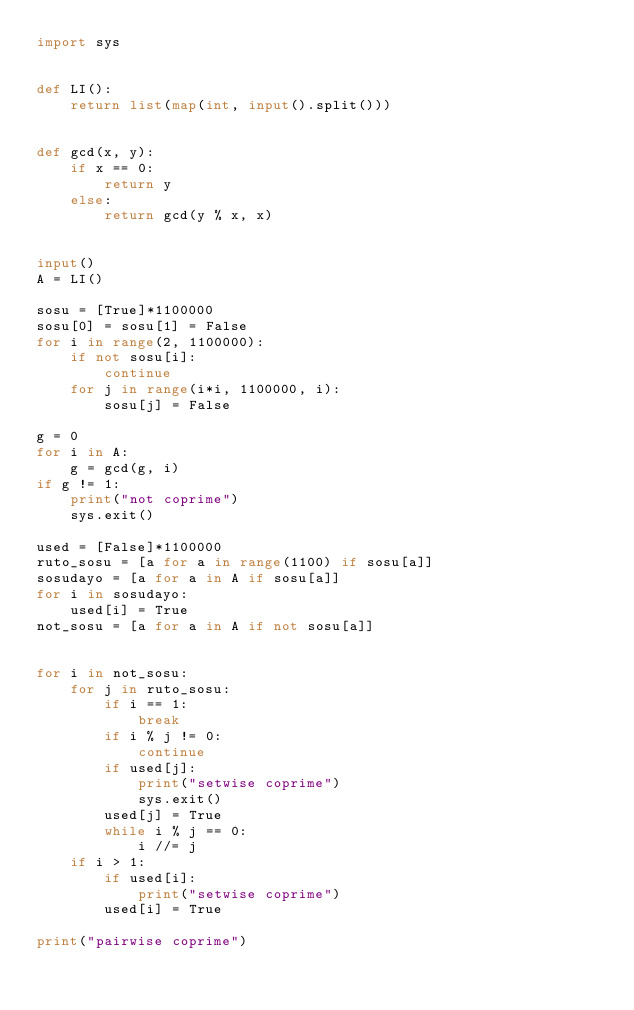Convert code to text. <code><loc_0><loc_0><loc_500><loc_500><_Python_>import sys


def LI():
    return list(map(int, input().split()))


def gcd(x, y):
    if x == 0:
        return y
    else:
        return gcd(y % x, x)


input()
A = LI()

sosu = [True]*1100000
sosu[0] = sosu[1] = False
for i in range(2, 1100000):
    if not sosu[i]:
        continue
    for j in range(i*i, 1100000, i):
        sosu[j] = False

g = 0
for i in A:
    g = gcd(g, i)
if g != 1:
    print("not coprime")
    sys.exit()

used = [False]*1100000
ruto_sosu = [a for a in range(1100) if sosu[a]]
sosudayo = [a for a in A if sosu[a]]
for i in sosudayo:
    used[i] = True
not_sosu = [a for a in A if not sosu[a]]


for i in not_sosu:
    for j in ruto_sosu:
        if i == 1:
            break
        if i % j != 0:
            continue
        if used[j]:
            print("setwise coprime")
            sys.exit()
        used[j] = True
        while i % j == 0:
            i //= j
    if i > 1:
        if used[i]:
            print("setwise coprime")
        used[i] = True

print("pairwise coprime")
</code> 